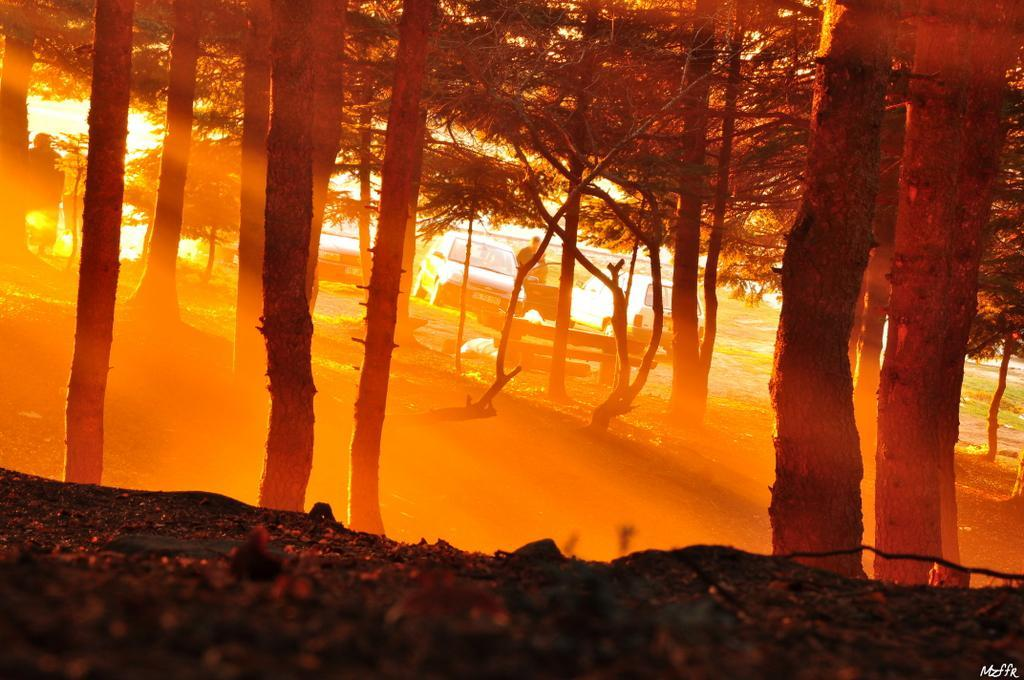What is the primary subject in the image? There is a person standing in the image. What type of natural environment is visible in the image? There are trees and grass in the image. What else can be seen in the image besides the person and natural elements? There are vehicles and a ground visible in the image. What shape is the oatmeal in the image? There is no oatmeal present in the image. How does the destruction in the image affect the person standing? There is no destruction present in the image, so it does not affect the person standing. 